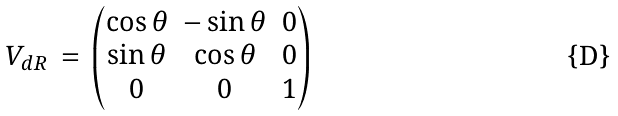<formula> <loc_0><loc_0><loc_500><loc_500>V _ { d R } \, = \, \begin{pmatrix} \cos \theta & - \sin \theta & 0 \\ \sin \theta & \cos \theta & 0 \\ 0 & 0 & 1 \end{pmatrix}</formula> 